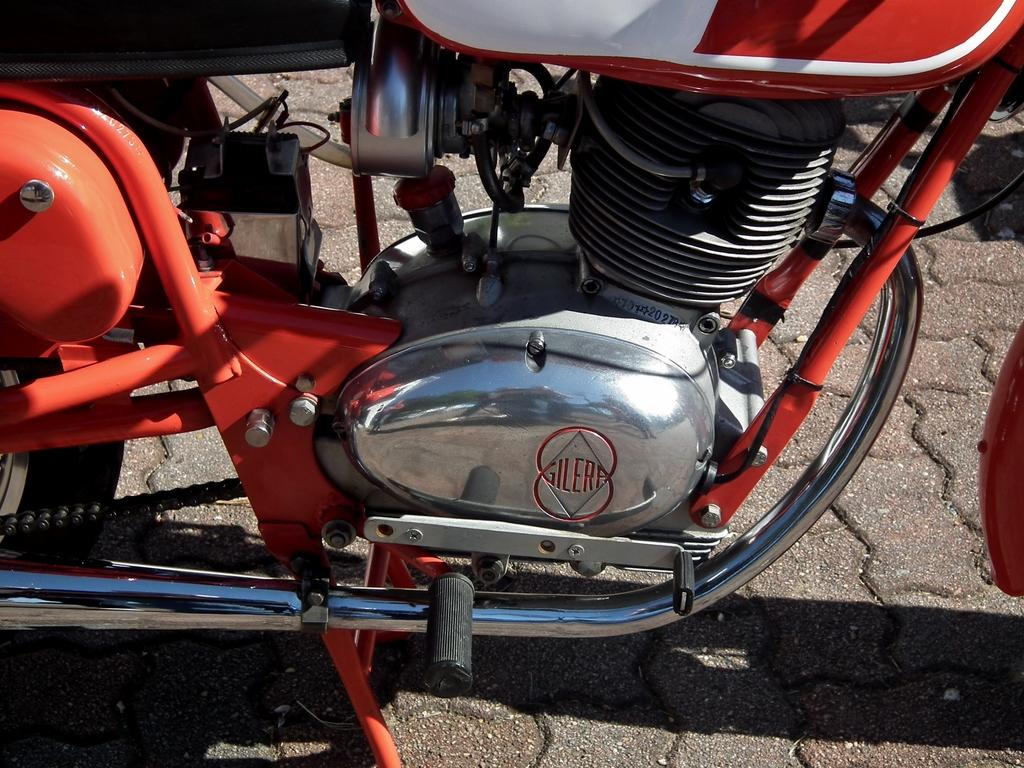What is the main subject of the image? The main subject of the image is a bike. Where is the bike located in the image? The bike is in the center of the image. What type of sponge is being used to clean the bike in the image? There is no sponge or cleaning activity present in the image; it simply shows a bike in the center. 